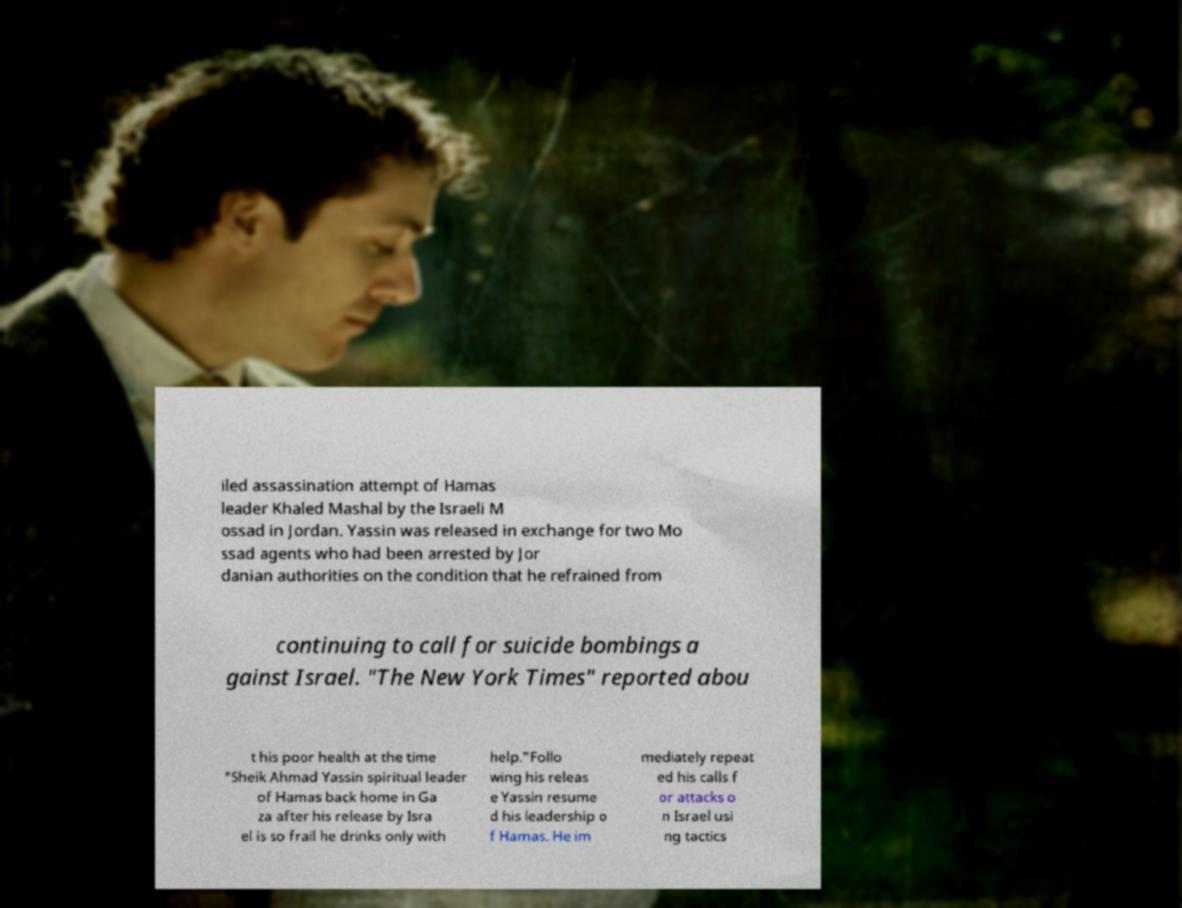Could you assist in decoding the text presented in this image and type it out clearly? iled assassination attempt of Hamas leader Khaled Mashal by the Israeli M ossad in Jordan. Yassin was released in exchange for two Mo ssad agents who had been arrested by Jor danian authorities on the condition that he refrained from continuing to call for suicide bombings a gainst Israel. "The New York Times" reported abou t his poor health at the time "Sheik Ahmad Yassin spiritual leader of Hamas back home in Ga za after his release by Isra el is so frail he drinks only with help."Follo wing his releas e Yassin resume d his leadership o f Hamas. He im mediately repeat ed his calls f or attacks o n Israel usi ng tactics 